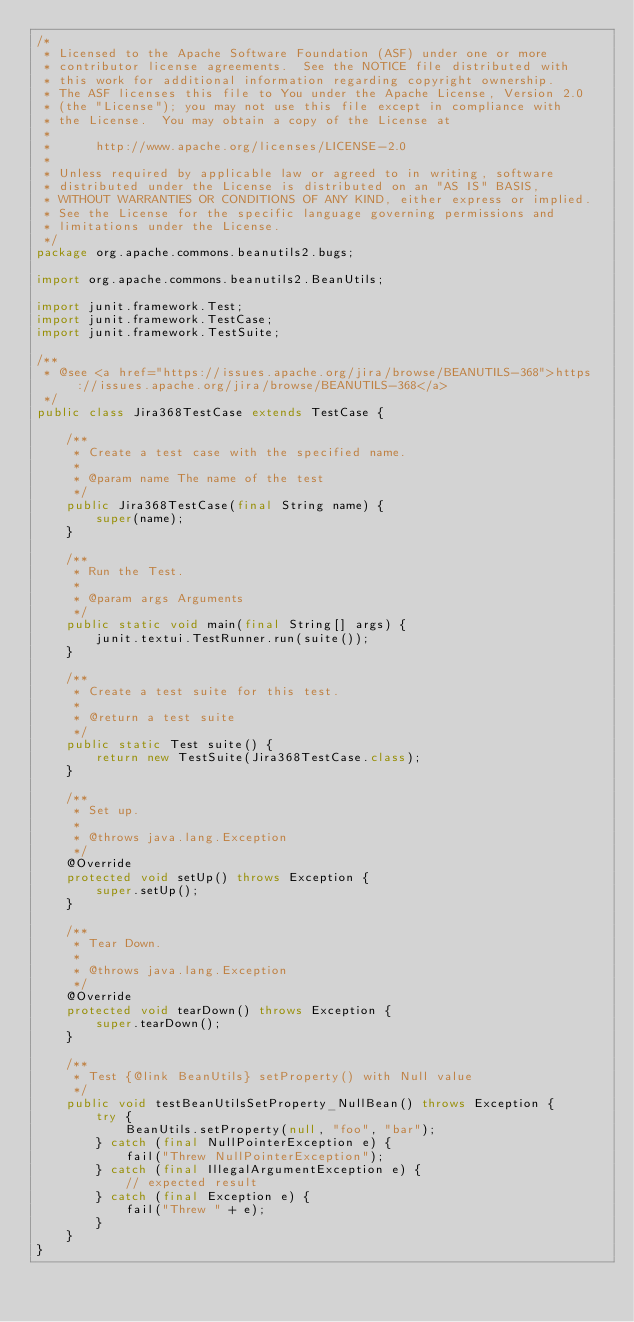<code> <loc_0><loc_0><loc_500><loc_500><_Java_>/*
 * Licensed to the Apache Software Foundation (ASF) under one or more
 * contributor license agreements.  See the NOTICE file distributed with
 * this work for additional information regarding copyright ownership.
 * The ASF licenses this file to You under the Apache License, Version 2.0
 * (the "License"); you may not use this file except in compliance with
 * the License.  You may obtain a copy of the License at
 *
 *      http://www.apache.org/licenses/LICENSE-2.0
 *
 * Unless required by applicable law or agreed to in writing, software
 * distributed under the License is distributed on an "AS IS" BASIS,
 * WITHOUT WARRANTIES OR CONDITIONS OF ANY KIND, either express or implied.
 * See the License for the specific language governing permissions and
 * limitations under the License.
 */
package org.apache.commons.beanutils2.bugs;

import org.apache.commons.beanutils2.BeanUtils;

import junit.framework.Test;
import junit.framework.TestCase;
import junit.framework.TestSuite;

/**
 * @see <a href="https://issues.apache.org/jira/browse/BEANUTILS-368">https://issues.apache.org/jira/browse/BEANUTILS-368</a>
 */
public class Jira368TestCase extends TestCase {

    /**
     * Create a test case with the specified name.
     *
     * @param name The name of the test
     */
    public Jira368TestCase(final String name) {
        super(name);
    }

    /**
     * Run the Test.
     *
     * @param args Arguments
     */
    public static void main(final String[] args) {
        junit.textui.TestRunner.run(suite());
    }

    /**
     * Create a test suite for this test.
     *
     * @return a test suite
     */
    public static Test suite() {
        return new TestSuite(Jira368TestCase.class);
    }

    /**
     * Set up.
     *
     * @throws java.lang.Exception
     */
    @Override
    protected void setUp() throws Exception {
        super.setUp();
    }

    /**
     * Tear Down.
     *
     * @throws java.lang.Exception
     */
    @Override
    protected void tearDown() throws Exception {
        super.tearDown();
    }

    /**
     * Test {@link BeanUtils} setProperty() with Null value
     */
    public void testBeanUtilsSetProperty_NullBean() throws Exception {
        try {
            BeanUtils.setProperty(null, "foo", "bar");
        } catch (final NullPointerException e) {
            fail("Threw NullPointerException");
        } catch (final IllegalArgumentException e) {
            // expected result
        } catch (final Exception e) {
            fail("Threw " + e);
        }
    }
}
</code> 